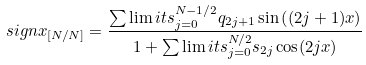Convert formula to latex. <formula><loc_0><loc_0><loc_500><loc_500>s i g n x _ { [ N / N ] } = \frac { \sum \lim i t s _ { j = 0 } ^ { N - 1 / 2 } q _ { 2 j + 1 } \sin \left ( ( 2 j + 1 ) x \right ) } { 1 + \sum \lim i t s _ { j = 0 } ^ { N / 2 } s _ { 2 j } \cos ( 2 j x ) }</formula> 